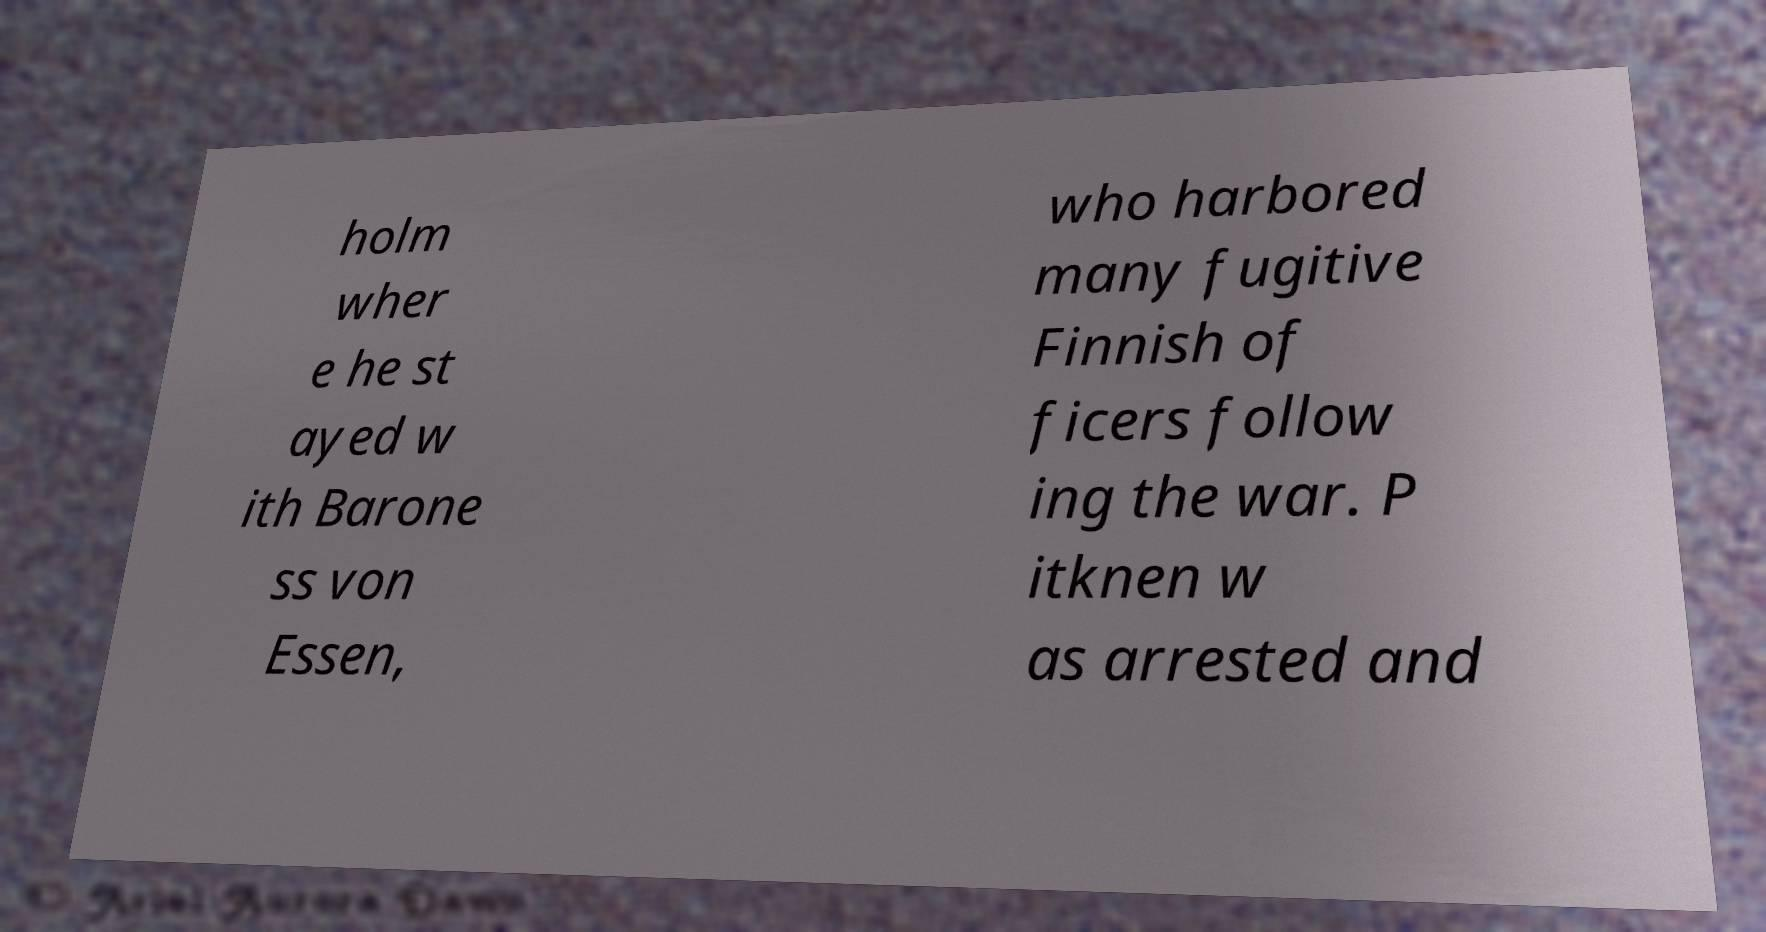Could you assist in decoding the text presented in this image and type it out clearly? holm wher e he st ayed w ith Barone ss von Essen, who harbored many fugitive Finnish of ficers follow ing the war. P itknen w as arrested and 